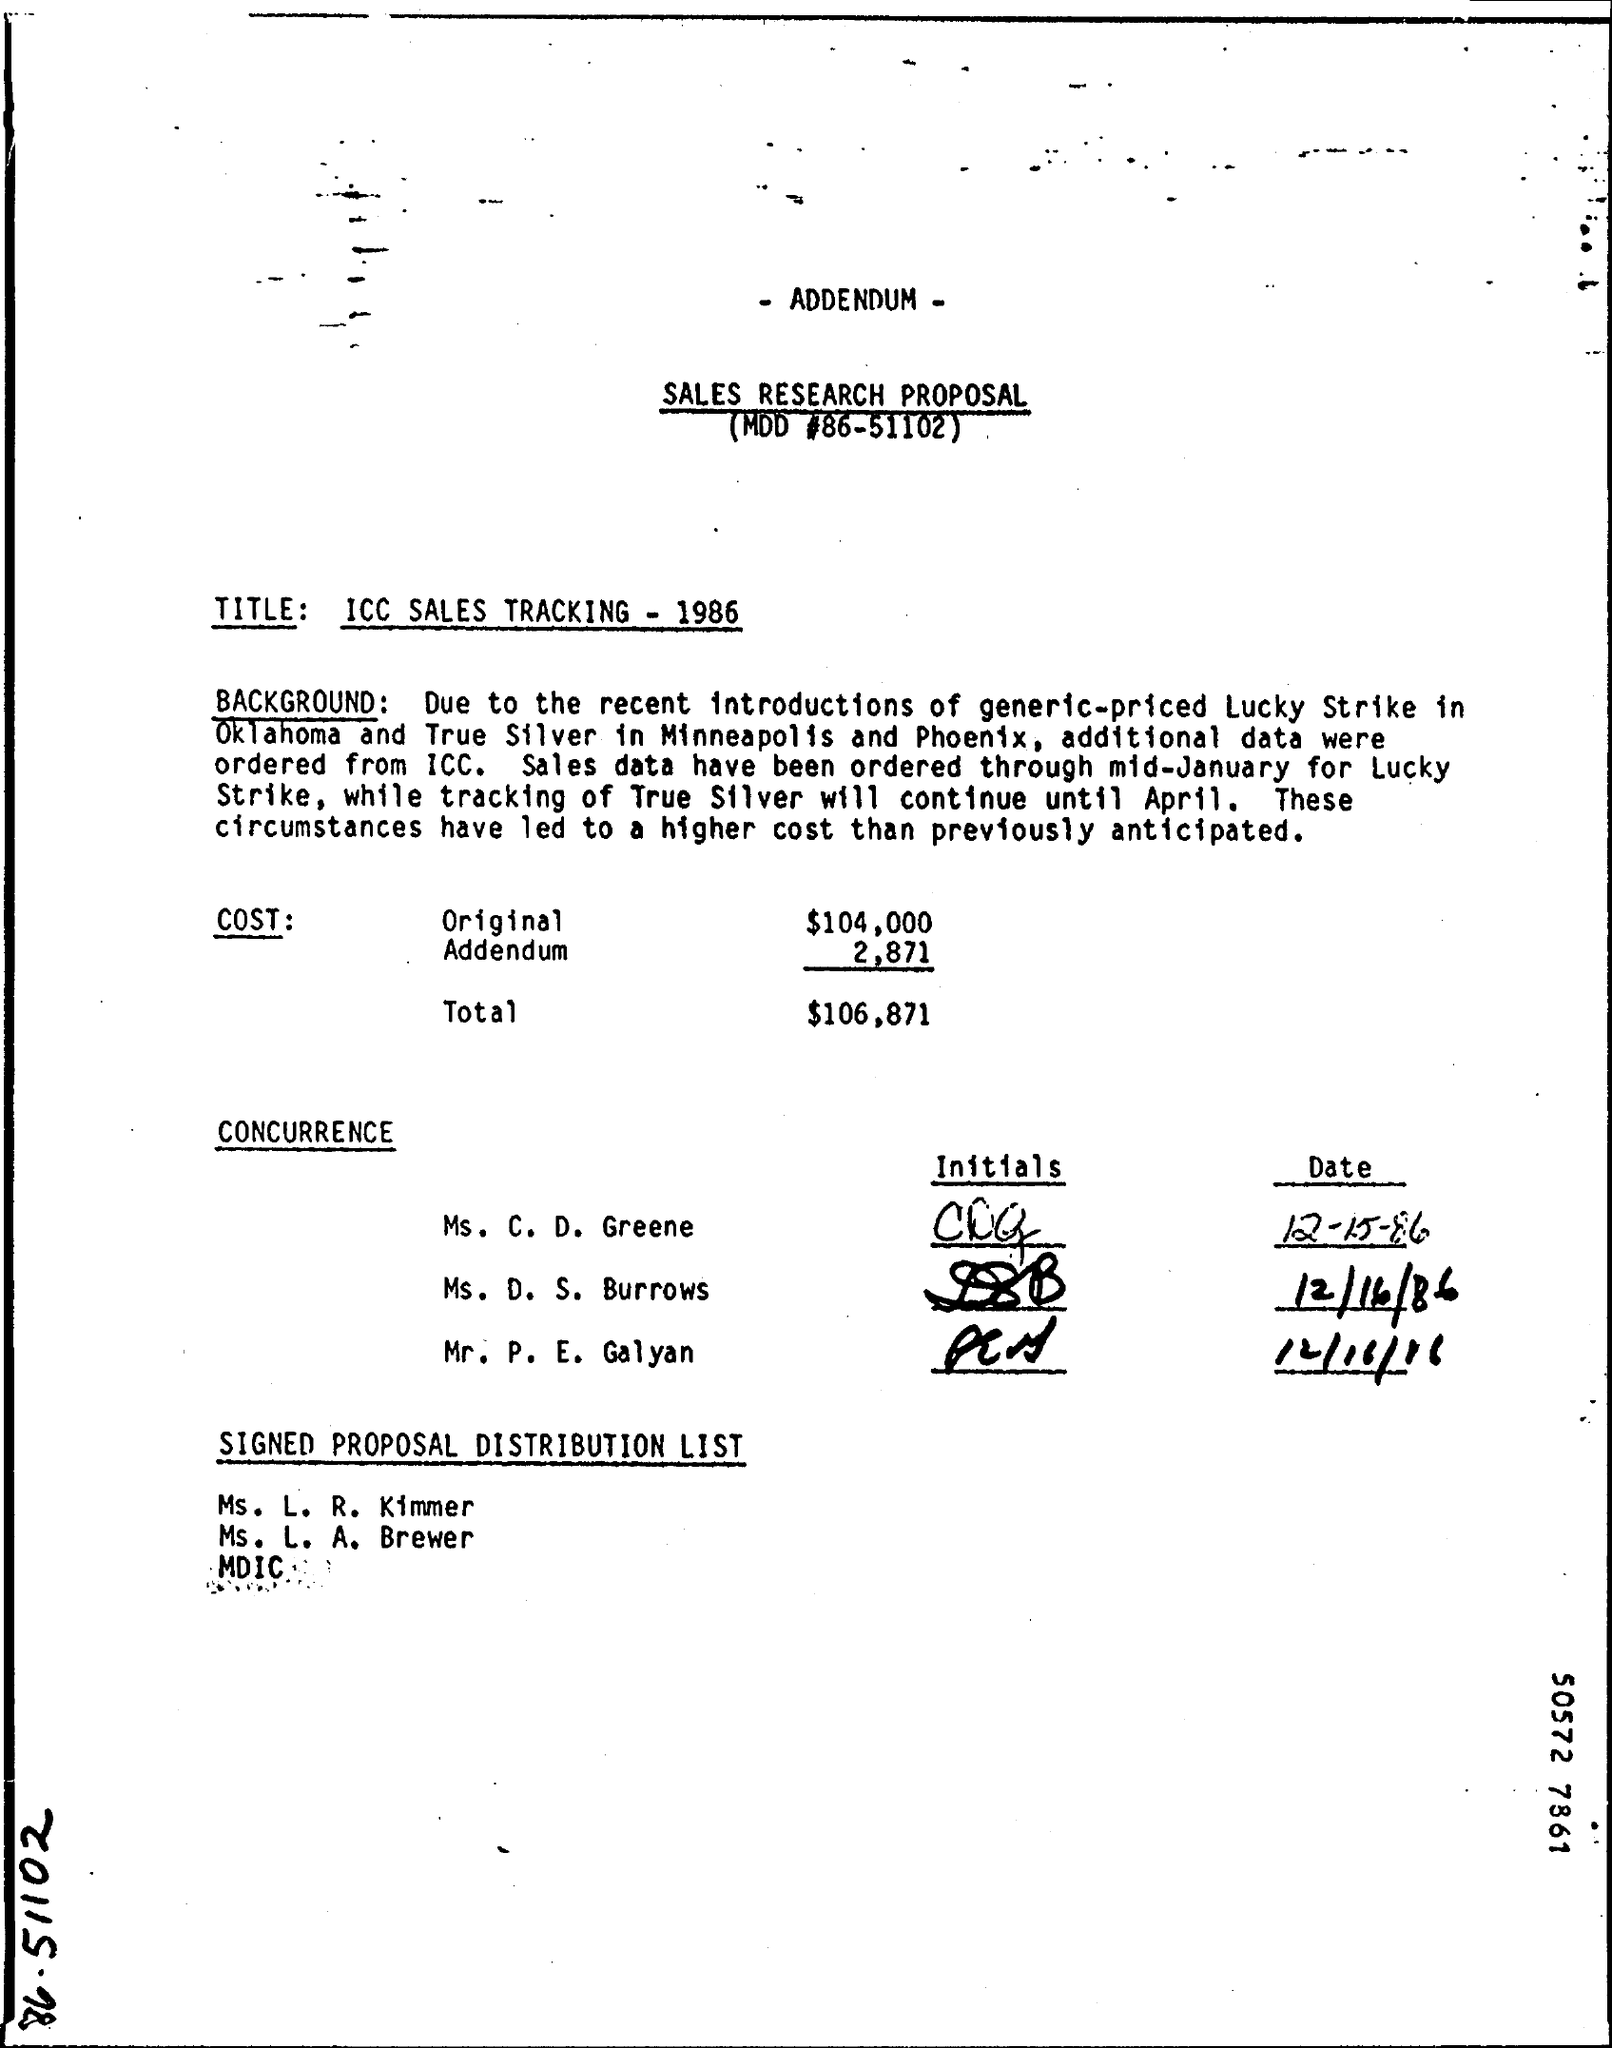What is the 'Title' of the Sales research proposal ?
Your answer should be very brief. ICC Sales Tracking - 1986. What is the Original cost ?
Offer a terse response. $104,000. What is the total cost ?
Your response must be concise. $106,871. Lucky Strike is introduced in which place?
Provide a succinct answer. Oklahoma. Tracking of True silver will continue until which month?
Offer a very short reply. April. 